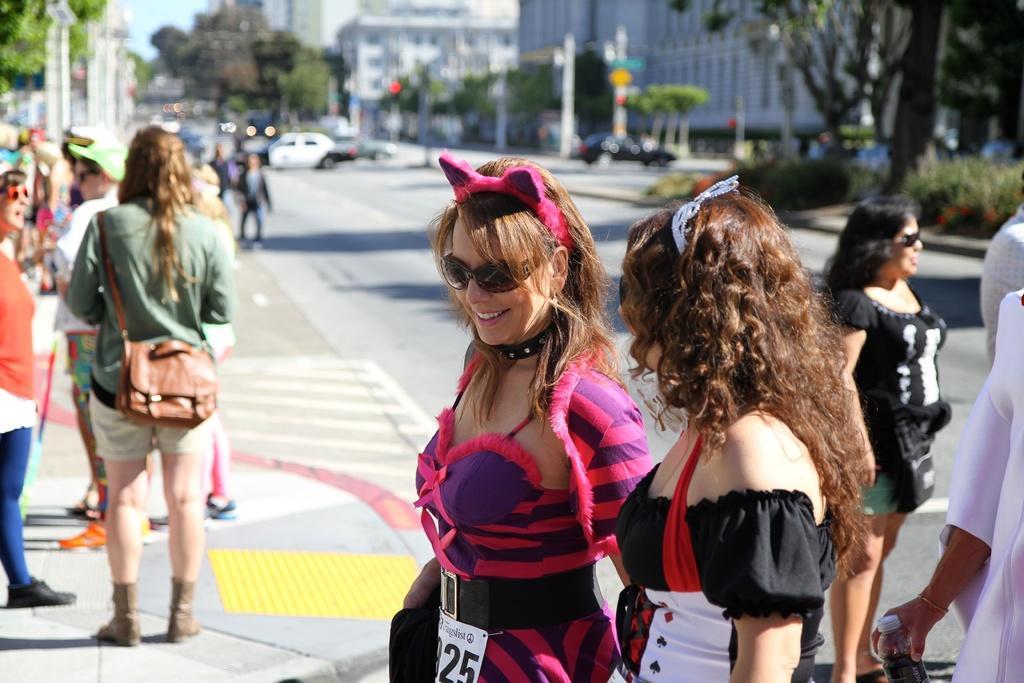In one or two sentences, can you explain what this image depicts? In this image I can see a road and on it I can see number of people are standing. I can also see few of them are wearing shades and on the right side I can see one of them is holding a bottle. In the background I can see number of trees, number of poles, a signal light, number of buildings, the sky and number of cars. I can also see this image is little bit blurry. 